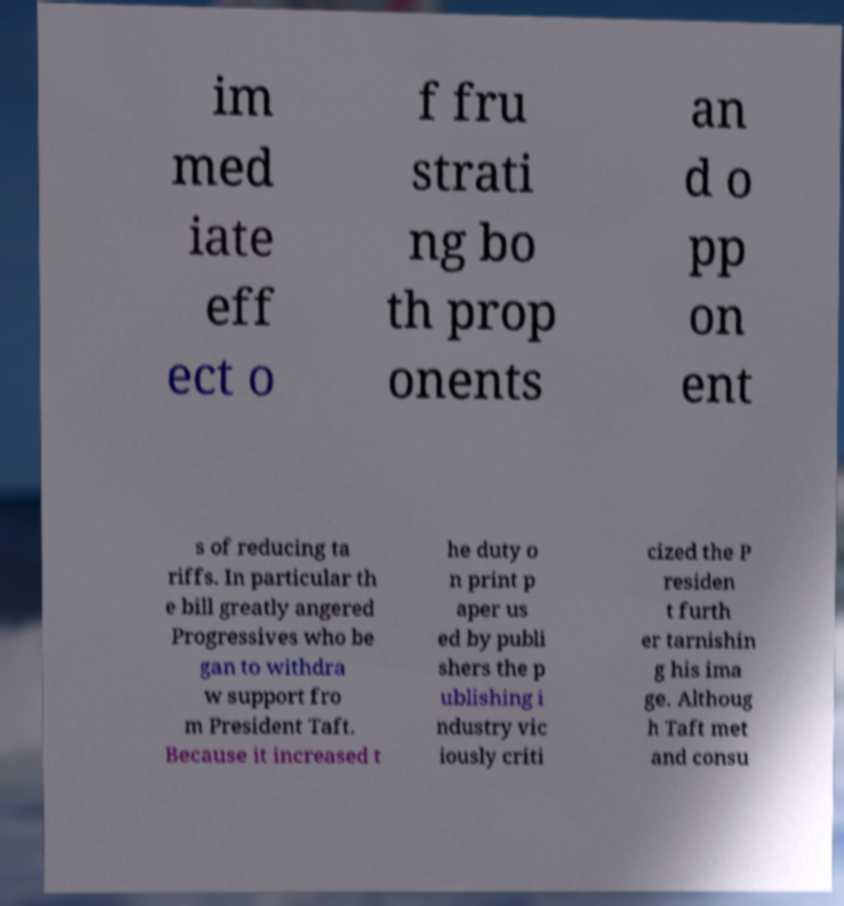I need the written content from this picture converted into text. Can you do that? im med iate eff ect o f fru strati ng bo th prop onents an d o pp on ent s of reducing ta riffs. In particular th e bill greatly angered Progressives who be gan to withdra w support fro m President Taft. Because it increased t he duty o n print p aper us ed by publi shers the p ublishing i ndustry vic iously criti cized the P residen t furth er tarnishin g his ima ge. Althoug h Taft met and consu 